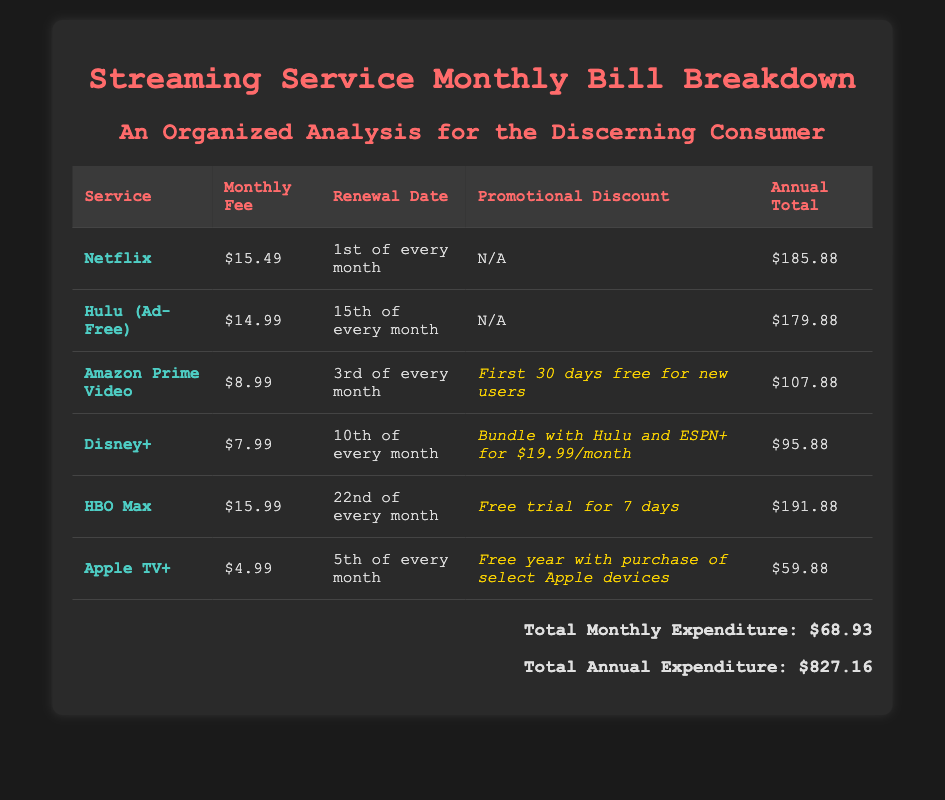What is the monthly fee for Netflix? The monthly fee for Netflix is provided in the table under the "Monthly Fee" column.
Answer: $15.49 When is the renewal date for Hulu (Ad-Free)? The renewal date for Hulu (Ad-Free) is mentioned in the table under the "Renewal Date" column.
Answer: 15th of every month What is the promotional discount for Amazon Prime Video? The promotional discount for Amazon Prime Video is specifically noted in the "Promotional Discount" column of the table.
Answer: First 30 days free for new users Which service has the lowest monthly fee? The lowest monthly fee can be determined by comparing the amounts listed in the "Monthly Fee" column of the table.
Answer: $4.99 What is the total annual expenditure? The total annual expenditure is calculated by summing the annual totals provided in the last section of the document.
Answer: $827.16 Which streaming service requires a purchase of select Apple devices for a free year? This information can be found under the "Promotional Discount" column for Apple TV+.
Answer: Apple TV+ How much is the monthly fee for Disney+? The monthly fee for Disney+ is found in the "Monthly Fee" column of the table.
Answer: $7.99 What day does HBO Max renew? The renewal day for HBO Max can be found in the "Renewal Date" column.
Answer: 22nd of every month What is the total monthly expenditure? The total monthly expenditure is stated at the bottom of the document after the table.
Answer: $68.93 